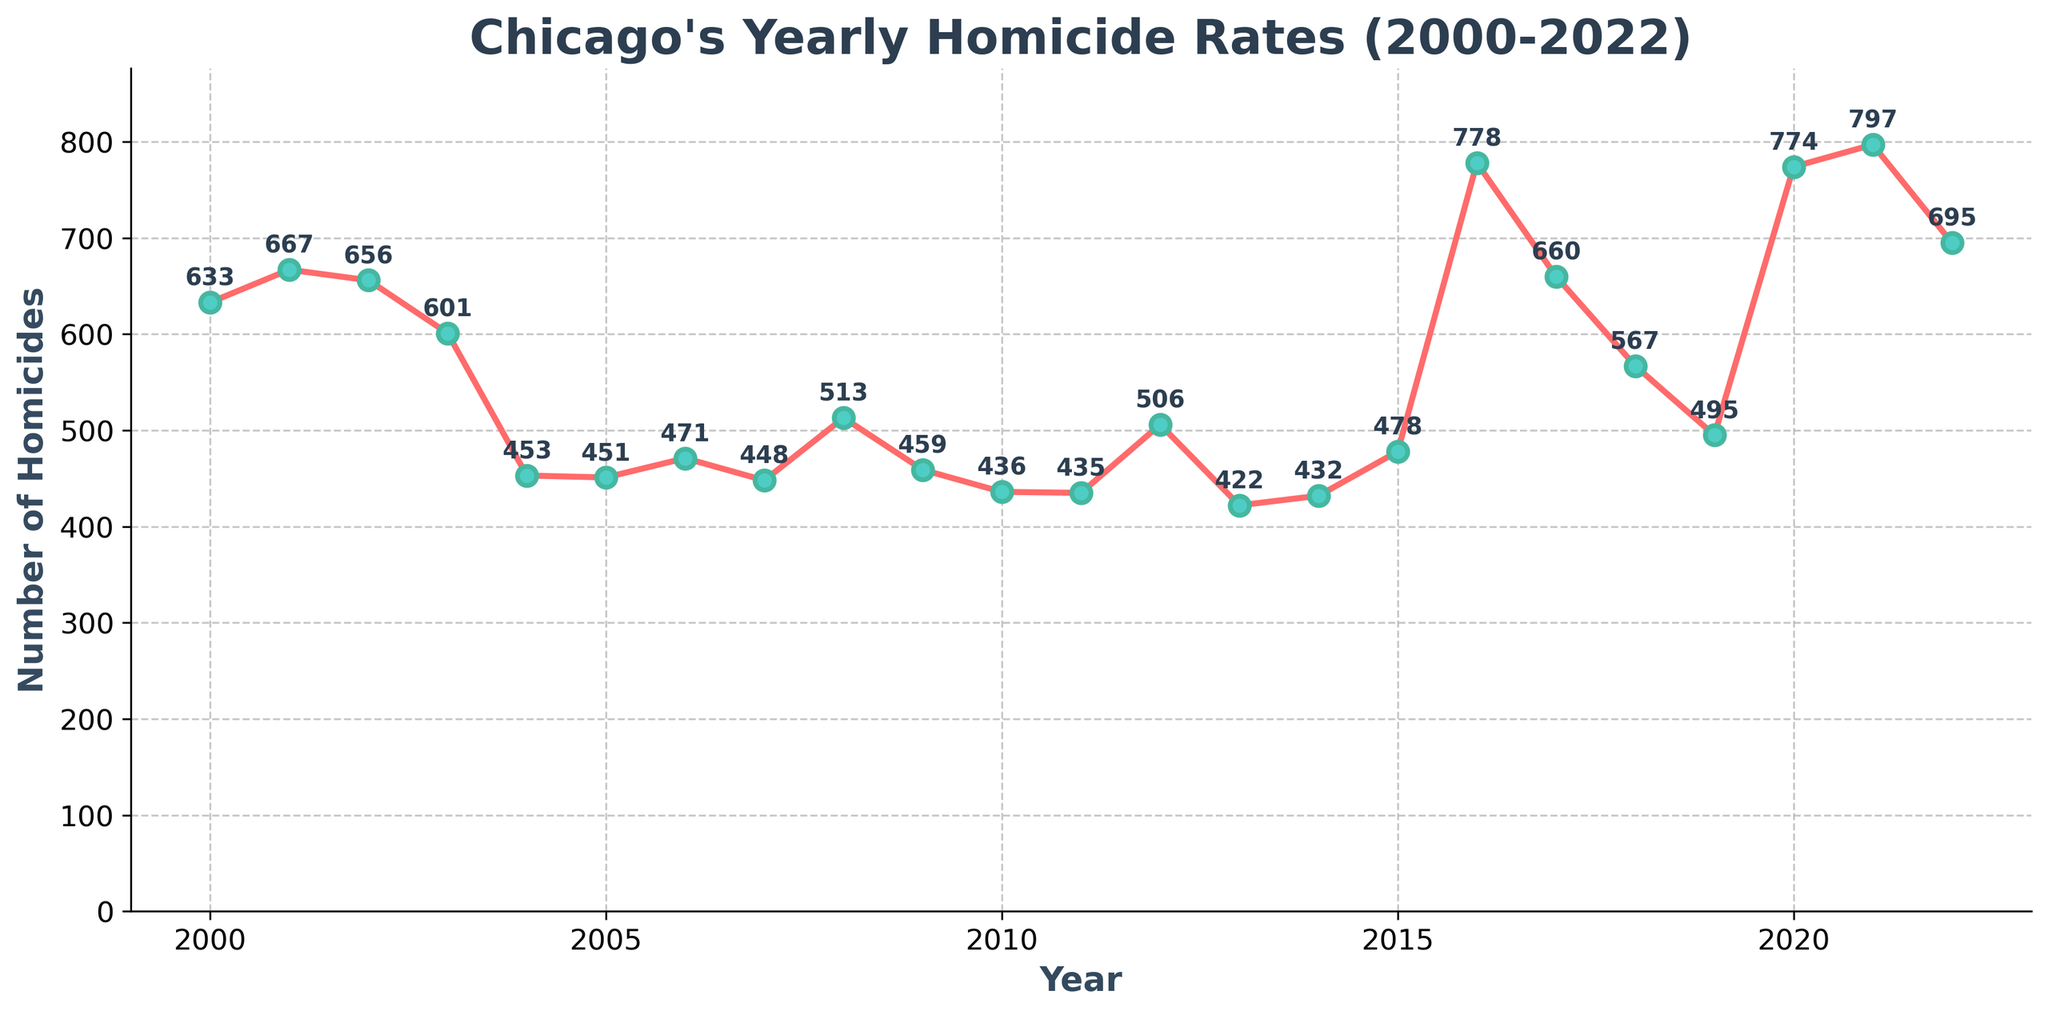What year had the highest number of homicides? To find this, look for the highest data point on the chart and note the corresponding year on the x-axis. The highest number of homicides is marked with an annotation.
Answer: 2016 Which year had lower homicides, 2007 or 2011? To answer this, compare the points for both years on the chart. The annotations show the figures next to each data point, with 2007 having 448 homicides and 2011 having 435 homicides. Since 435 is less than 448, 2011 had lower homicides.
Answer: 2011 How did the number of homicides change from 2004 to 2005? Look at the data points for 2004 and 2005. 2004 had 453 homicides and 2005 had 451 homicides. Subtract the 2005 number from 2004 to find the change.
Answer: Decreased by 2 What was the average number of homicides per year from 2000 to 2010? Calculate the average by summing the homicides from 2000 to 2010 and dividing by the number of years. Sum = 633 + 667 + 656 + 601 + 453 + 451 + 471 + 448 + 513 + 459 + 436 = 5688. Divide by 11 (years).
Answer: 517.09 Compare the homicides of 2018 and 2022; which year had more homicides? Look at the data points for 2018 and 2022. 2018 had 567 homicides and 2022 had 695 homicides. Since 695 is greater than 567, 2022 had more homicides.
Answer: 2022 What's the difference in the number of homicides between the highest and lowest years? Identify the highest (778 in 2016) and lowest (422 in 2013) numbers of homicides and subtract the lowest from the highest.
Answer: 356 What is the trend in homicide rates from 2019 to 2022? Observe the data points from 2019 to 2022. 2019 had 495, 2020 had 774, 2021 had 797, and 2022 had 695. This shows a rising trend from 2019 to 2021 and a slight decrease in 2022.
Answer: Mostly increasing, then slight decrease Did any year between 2015 to 2022 have fewer homicides than in 2000? Compare the data points for each year from 2015 to 2022 to the year 2000, which had 633 homicides. 2015 (478), 2017 (660), 2018 (567), 2019 (495), and 2022 (695) had fewer homicides than 2000.
Answer: Yes How many years had homicide rates over 600? Count all data points with homicides greater than 600. Those years are 2000, 2001, 2002, 2003, 2016, 2017, 2020, and 2021.
Answer: 8 